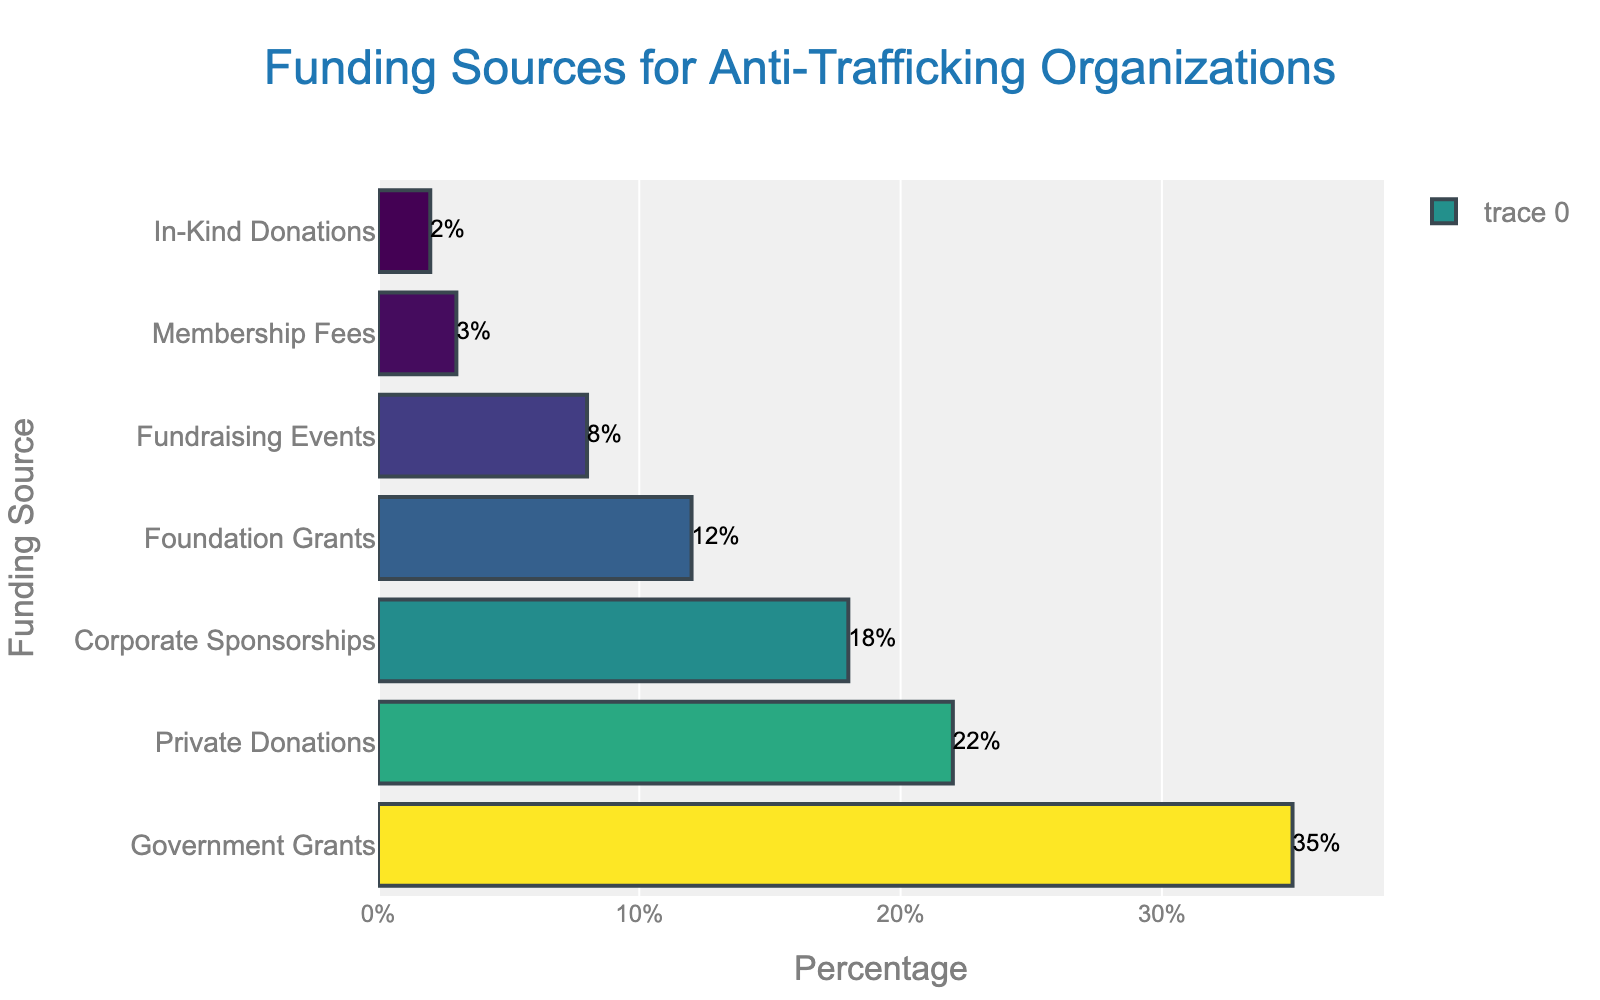what is the most common funding source for anti-trafficking organizations? The figure shows that "Government Grants" has the longest bar and the highest percentage among all categories.
Answer: Government Grants Which funding source has a higher percentage: Foundation Grants or Private Donations? By comparing the lengths of the bars, "Private Donations" has a longer bar than "Foundation Grants". Specifically, Private Donations is 22%, and Foundation Grants is 12%.
Answer: Private Donations What is the difference in percentage between the highest and the lowest funding source? The highest source is Government Grants at 35%, and the lowest is In-Kind Donations at 2%. The difference is 35% - 2% = 33%.
Answer: 33% How many funding sources have a percentage that is higher than 10%? By examining the figure, four categories have percentages higher than 10%: Government Grants (35%), Private Donations (22%), Corporate Sponsorships (18%), and Foundation Grants (12%).
Answer: 4 If we combine the percentages for Fundraising Events and Membership Fees, does this combined percentage exceed Corporate Sponsorships? Fundraising Events has 8% and Membership Fees has 3%. Their combined percentage is 8% + 3% = 11%, which is less than the 18% for Corporate Sponsorships.
Answer: No Are Private Donations and Corporate Sponsorships, combined, more than Government Grants? Private Donations is 22% and Corporate Sponsorships is 18%. Combined, they make 22% + 18% = 40%, which exceeds Government Grants' 35%.
Answer: Yes Which is closer to Foundation Grants in terms of percentage: Membership Fees or In-Kind Donations? Foundation Grants is 12%, Membership Fees is 3%, and In-Kind Donations is 2%. The differences are 12% - 3% = 9% for Membership Fees and 12% - 2% = 10% for In-Kind Donations. Therefore, Membership Fees is closer.
Answer: Membership Fees What is the average percentage of funding from Government Grants, Private Donations, and Corporate Sponsorships? The percentages are 35%, 22%, and 18%. The sum is 35 + 22 + 18 = 75. The average is 75 / 3 = 25.
Answer: 25 How does the color of the bar for Foundation Grants compare to that of Fundraising Events? The figure uses a colorscale where the color intensity increases with the percentage. As Foundation Grants (12%) has a higher percentage than Fundraising Events (8%), its bar has a darker shade than that of Fundraising Events.
Answer: Darker What is the combined percentage of Funding sources that contribute less than 10% each? Fundraising Events (8%), Membership Fees (3%), and In-Kind Donations (2%) each contribute less than 10%. Their combined percentage is 8% + 3% + 2% = 13%.
Answer: 13 